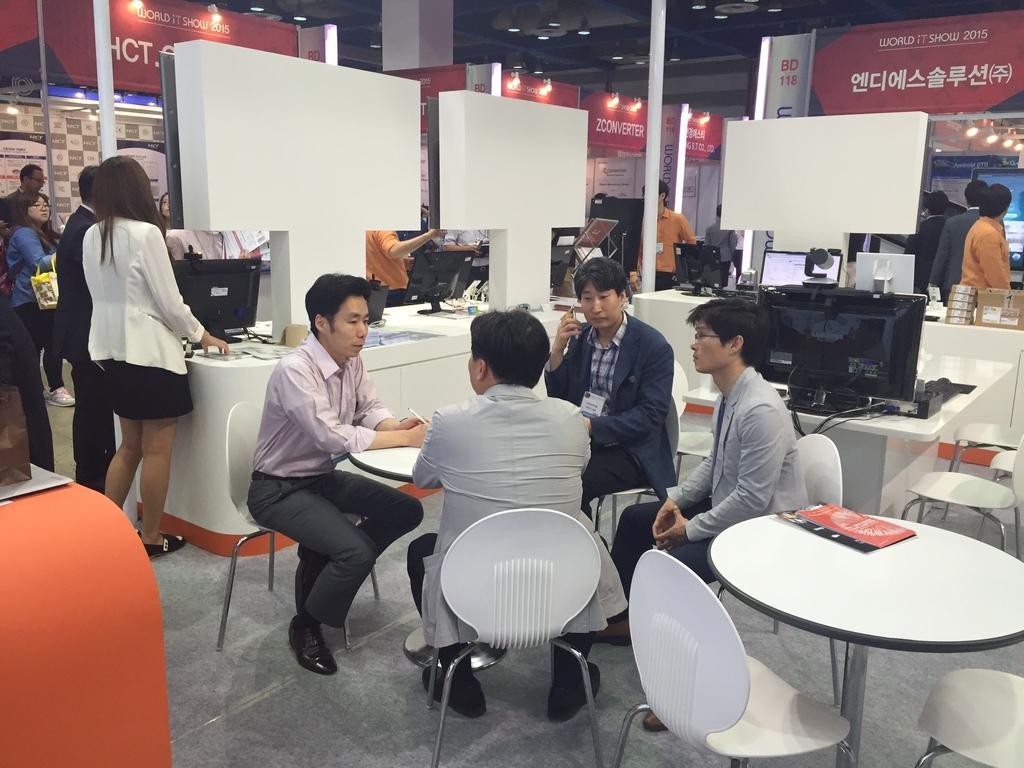Please provide a concise description of this image. In this image there are group of people. In the middle of the image there are four persons who are sitting and talking with each other. On the left side there are group of people who are standing, and on the right side there is one monitor and on the bottom of the right corner there is one table and two chairs. On the left side there is one table, and four chairs and on the top of the image there is one pole and one ceiling. On the top of the right corner there are group of people who are standing, and in the middle of the image there is one table and two screens and some computers are there on the table. 